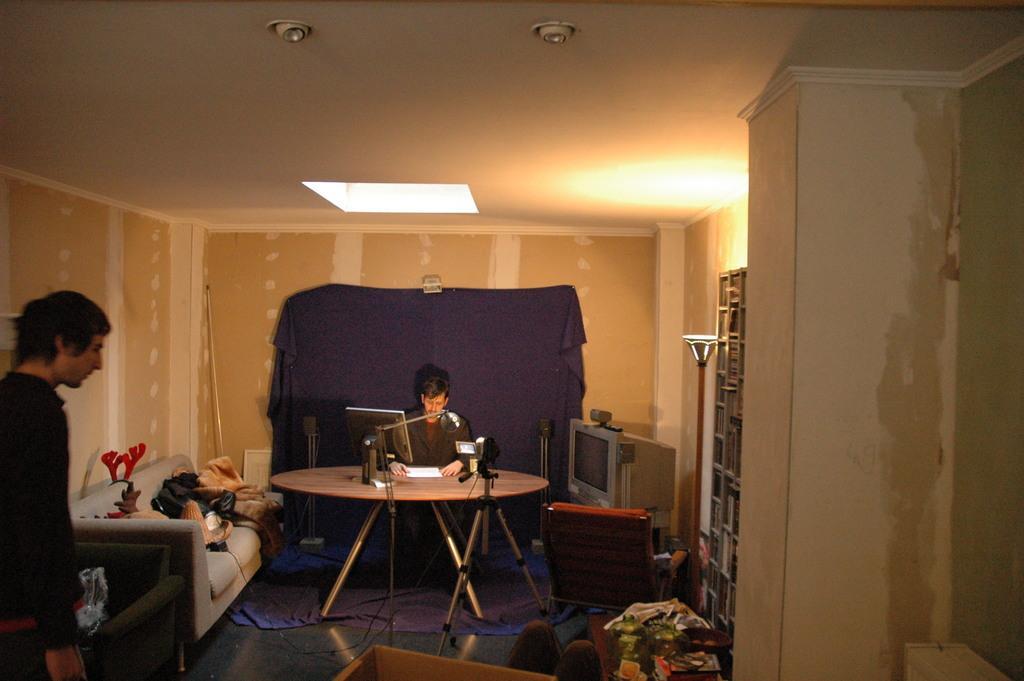Describe this image in one or two sentences. This is the picture taken in a room , there is a man sitting on a chair in front of the man there is a table on the table there is a monitor, paper. In front of the table there is a tripod stand with camera. There is other man standing on the floor and there is a sofa on the sofa there is a cloth and some items. Background of this people is a wall on the wall there is a cloth which is in blue color. 